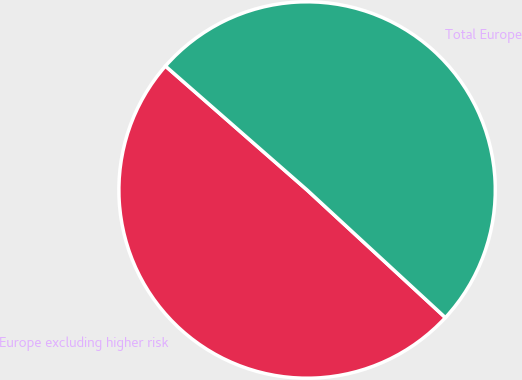Convert chart to OTSL. <chart><loc_0><loc_0><loc_500><loc_500><pie_chart><fcel>Europe excluding higher risk<fcel>Total Europe<nl><fcel>49.58%<fcel>50.42%<nl></chart> 